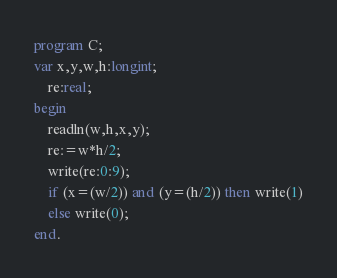<code> <loc_0><loc_0><loc_500><loc_500><_Pascal_>program C;
var x,y,w,h:longint;
    re:real;
begin
	readln(w,h,x,y);
	re:=w*h/2;
	write(re:0:9);
	if (x=(w/2)) and (y=(h/2)) then write(1)
	else write(0);
end.</code> 